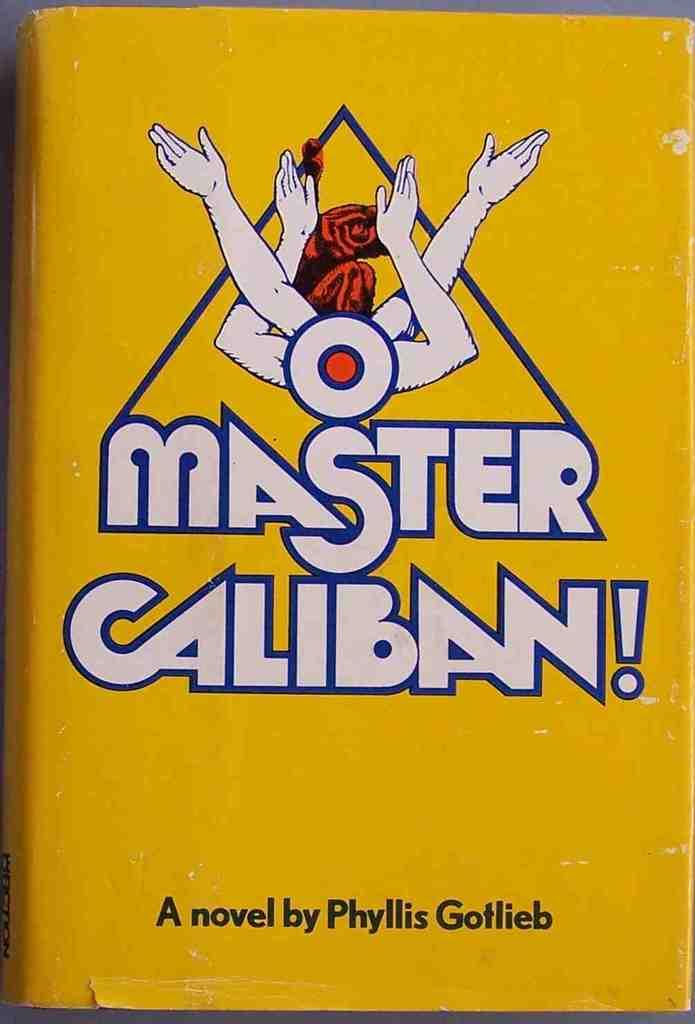Provide a one-sentence caption for the provided image. A novel with a bright yellow cover is written by Phyllis Gotlieb. 